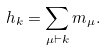Convert formula to latex. <formula><loc_0><loc_0><loc_500><loc_500>h _ { k } = \sum _ { \mu \vdash k } m _ { \mu } .</formula> 